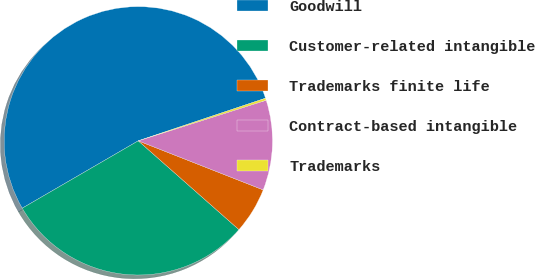Convert chart to OTSL. <chart><loc_0><loc_0><loc_500><loc_500><pie_chart><fcel>Goodwill<fcel>Customer-related intangible<fcel>Trademarks finite life<fcel>Contract-based intangible<fcel>Trademarks<nl><fcel>53.23%<fcel>30.12%<fcel>5.55%<fcel>10.85%<fcel>0.25%<nl></chart> 